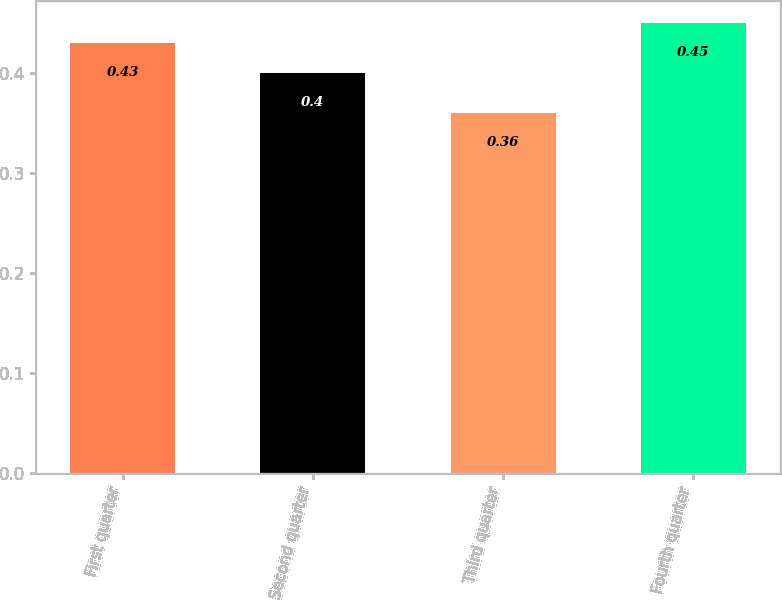Convert chart. <chart><loc_0><loc_0><loc_500><loc_500><bar_chart><fcel>First quarter<fcel>Second quarter<fcel>Third quarter<fcel>Fourth quarter<nl><fcel>0.43<fcel>0.4<fcel>0.36<fcel>0.45<nl></chart> 